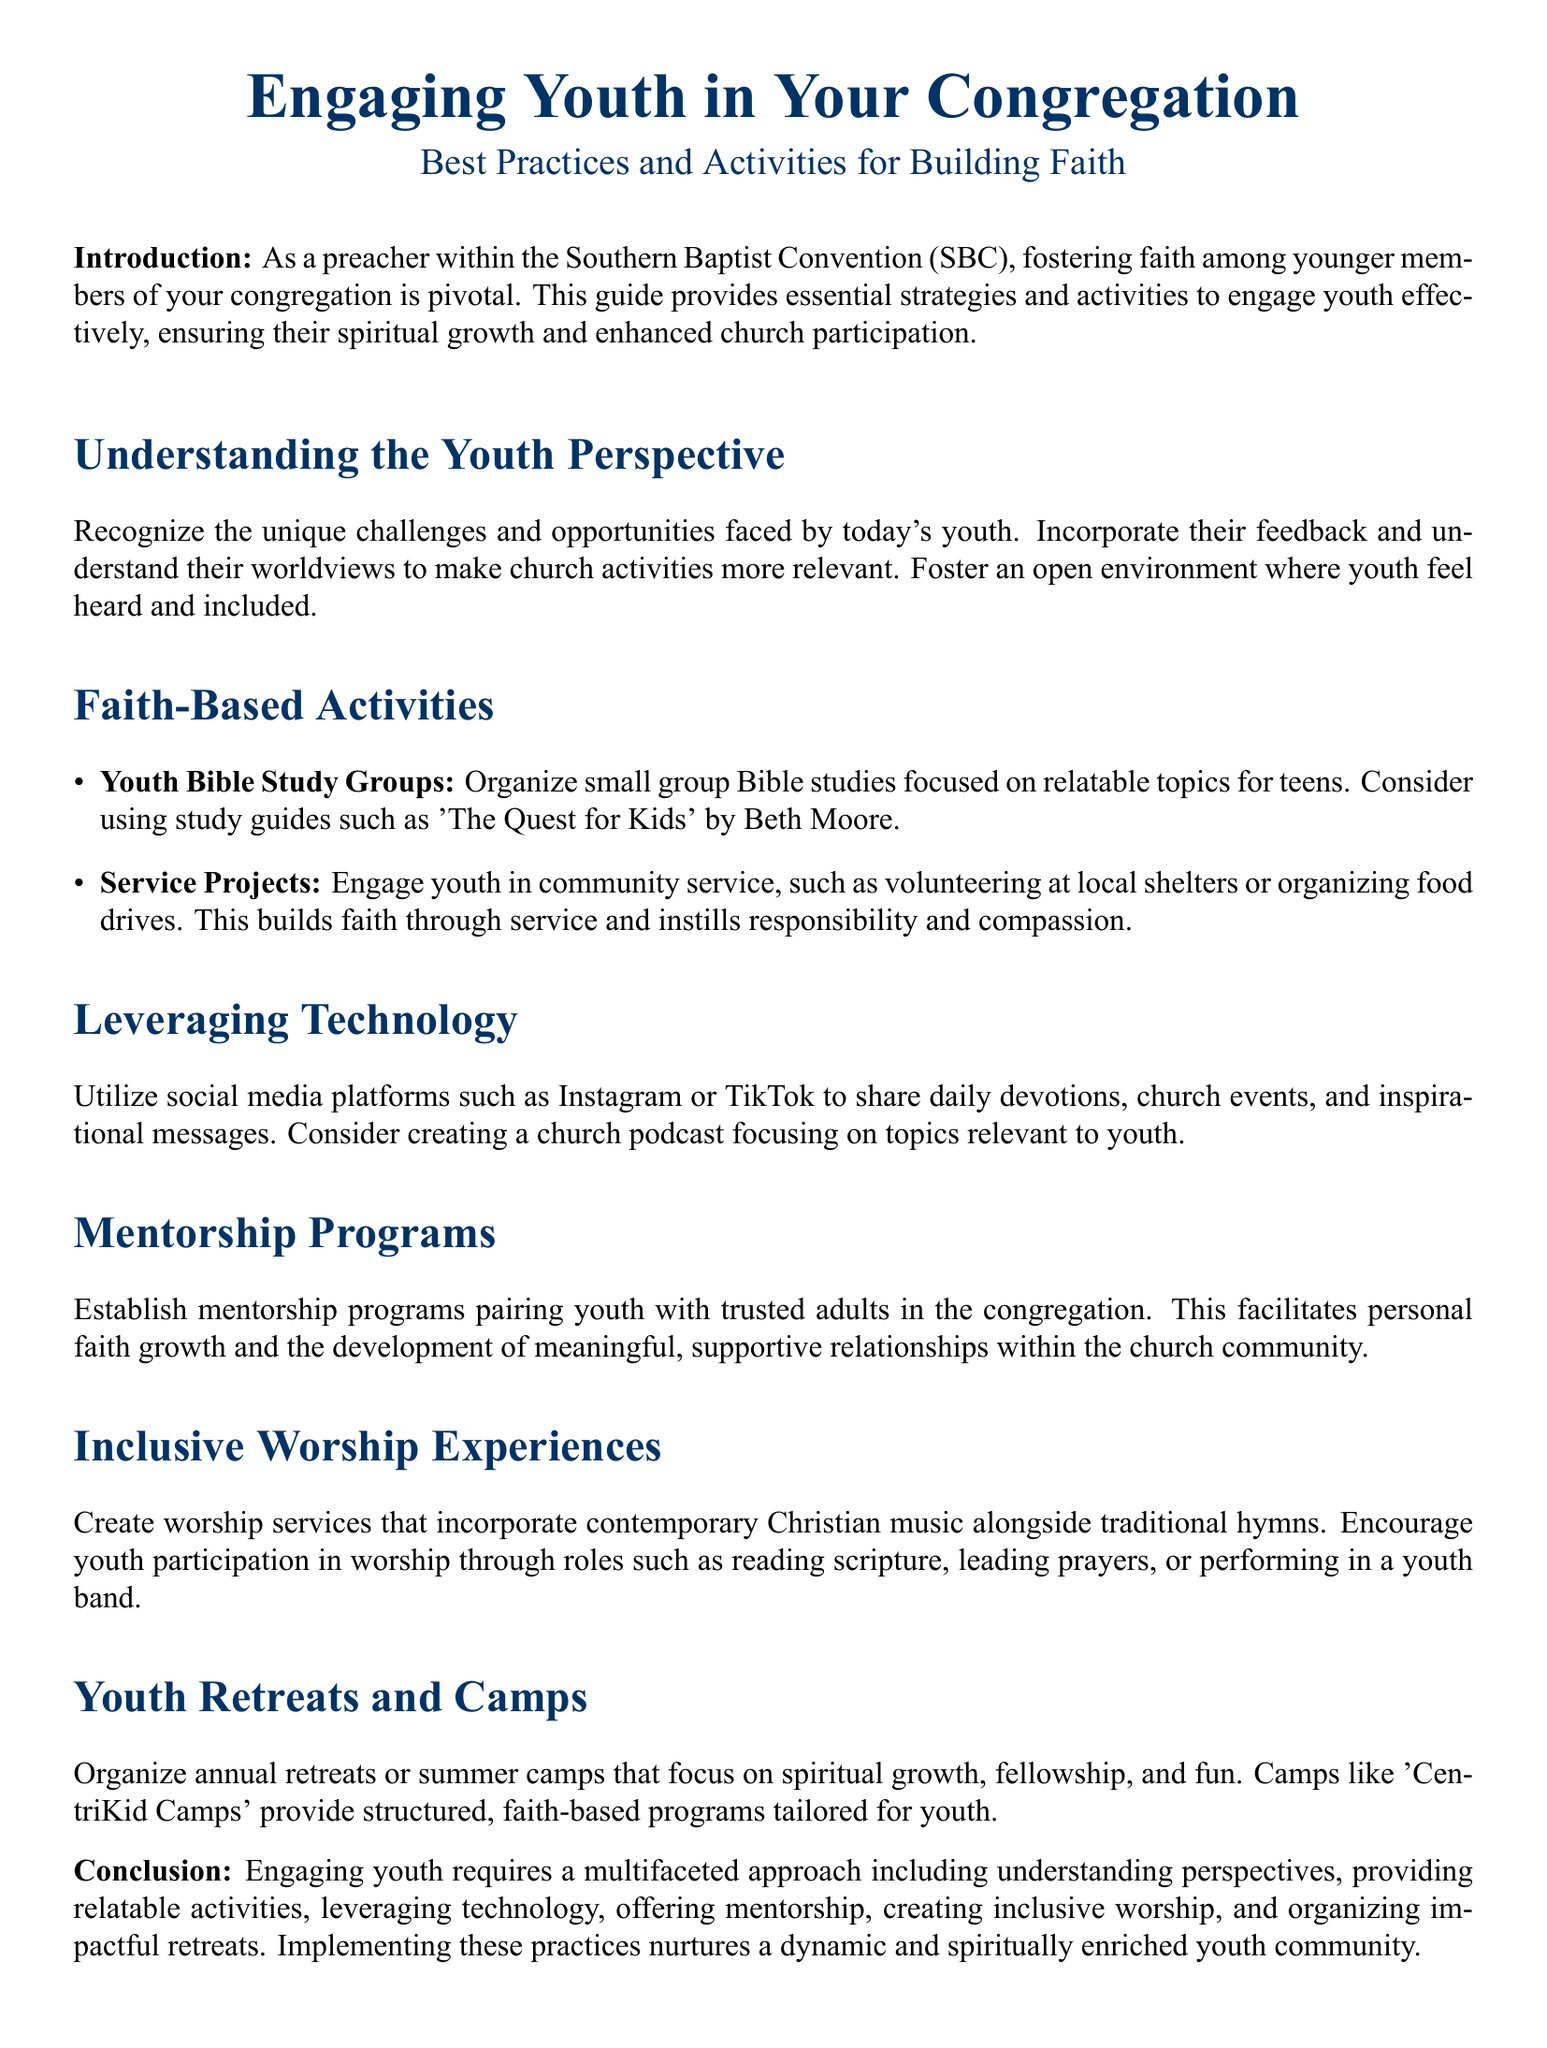What is the title of the guide? The title of the guide is prominently displayed at the beginning of the document.
Answer: Engaging Youth in Your Congregation What is one of the activities mentioned for youth engagement? The document lists specific activities aimed at engaging youth within the congregation.
Answer: Youth Bible Study Groups What color is used for the document's headings? The document specifies a particular color to be used for headings, which is defined in the code.
Answer: SBC blue How many categories of engagement strategies are mentioned? The document outlines different strategies and activities for engaging youth, which can be counted in a specific section.
Answer: Six What type of music is encouraged in worship experiences? The guide suggests incorporating different musical styles into worship, which is mentioned directly.
Answer: Contemporary Christian music What is the purpose of mentorship programs? The document explains the role of mentorship programs in fostering relationships and faith growth.
Answer: Personal faith growth What is one of the recommended summer camps mentioned? A specific camp is highlighted as an effective option for spiritual growth among youth in the document.
Answer: CentriKid Camps What type of platform is suggested for sharing daily devotions? The document recommends using popular platforms for engaging youth, which are noted in the relevant section.
Answer: Social media platforms 